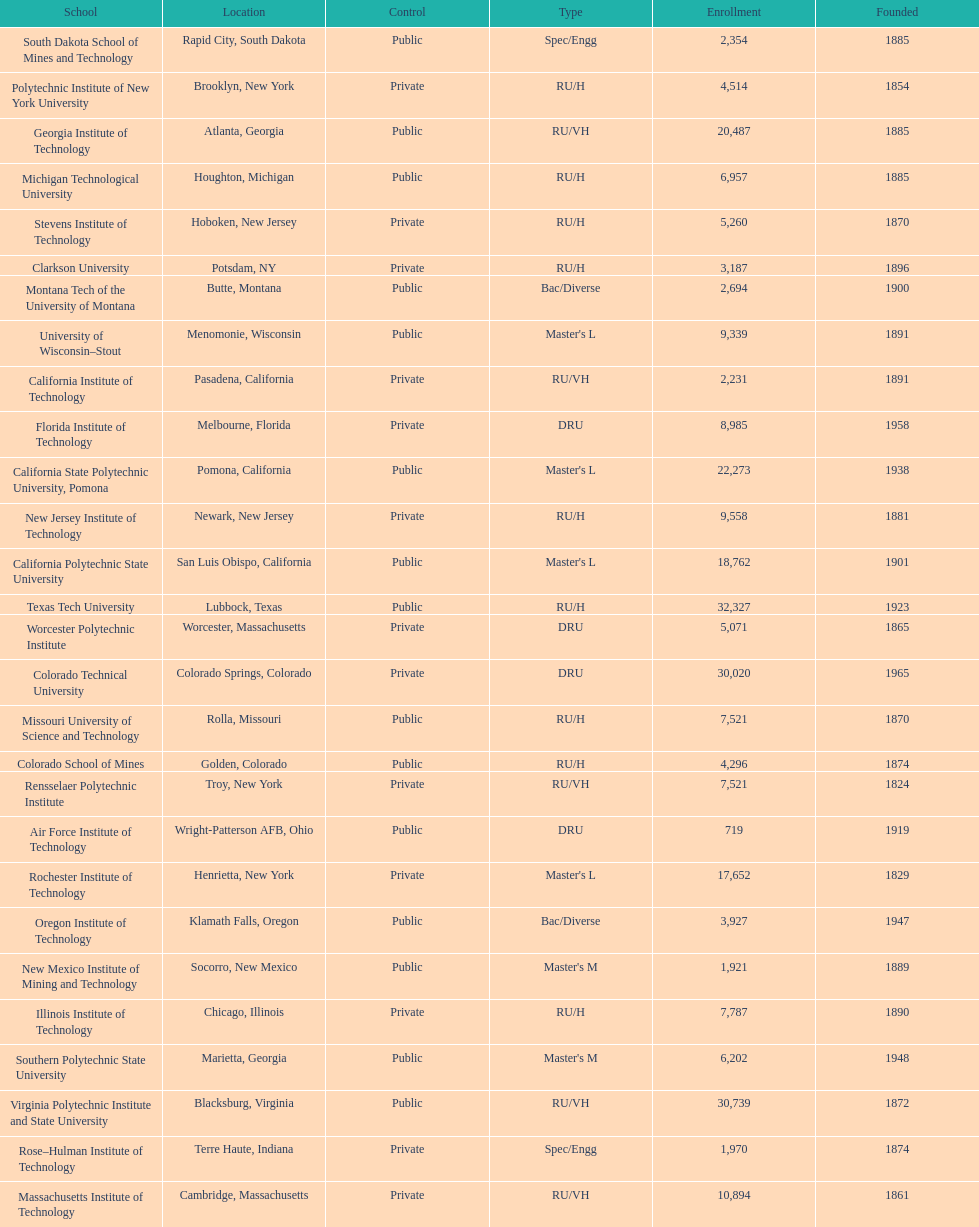What school is listed next after michigan technological university? Missouri University of Science and Technology. 